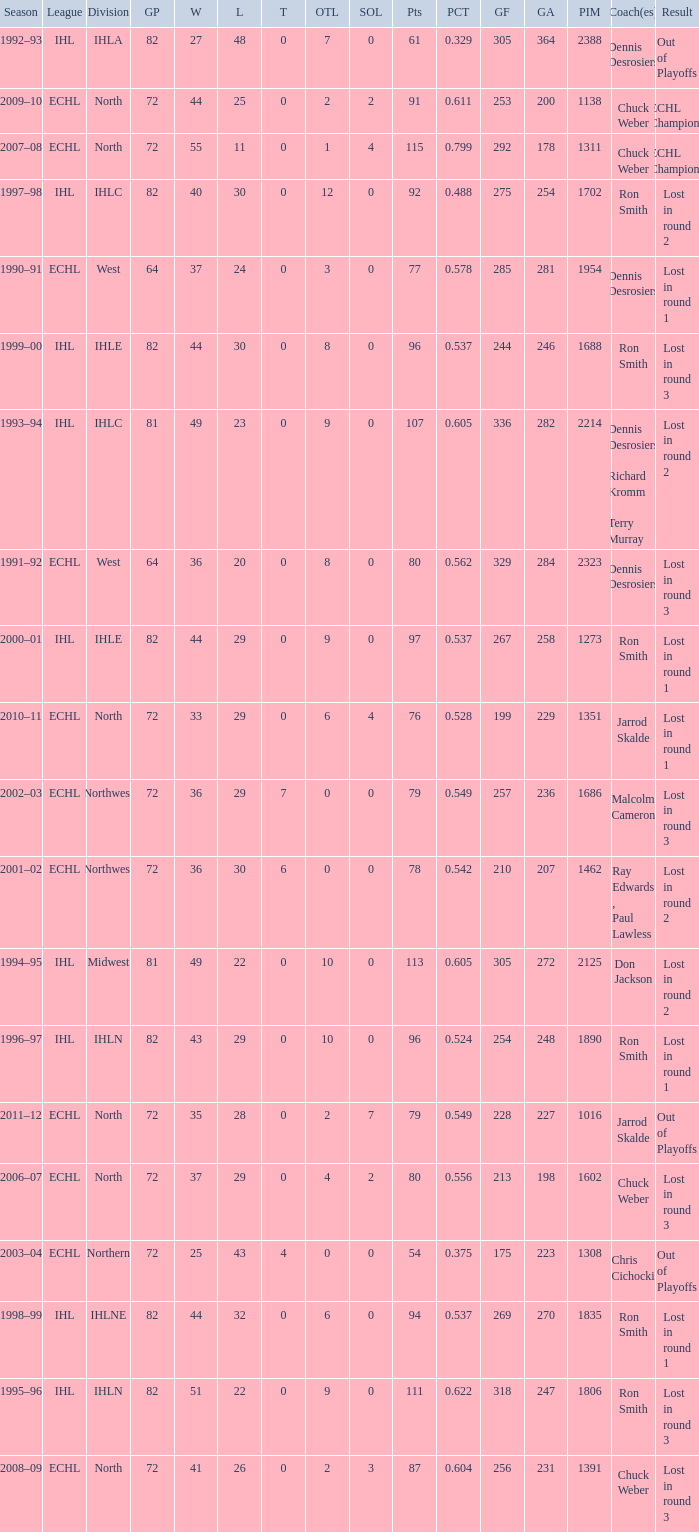What was the highest SOL where the team lost in round 3? 3.0. 